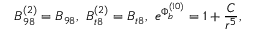Convert formula to latex. <formula><loc_0><loc_0><loc_500><loc_500>B _ { 9 8 } ^ { ( 2 ) } = B _ { 9 8 } , B _ { t 8 } ^ { ( 2 ) } = B _ { t 8 } , e ^ { { \Phi } _ { b } ^ { ( 1 0 ) } } = { { 1 + { \frac { C } { r ^ { 5 } } } } } ,</formula> 